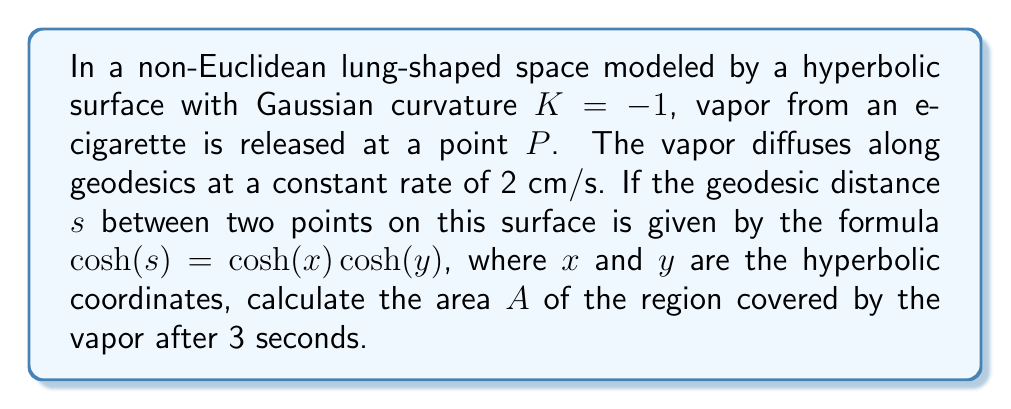Can you answer this question? To solve this problem, we'll follow these steps:

1) In hyperbolic geometry, the area of a circle with radius $r$ is given by:

   $$A = 4\pi\sinh^2(\frac{r}{2})$$

2) The vapor diffuses at a rate of 2 cm/s for 3 seconds, so the radius of the covered region is:

   $$r = 2 \text{ cm/s} \times 3 \text{ s} = 6 \text{ cm}$$

3) Substituting this into the area formula:

   $$A = 4\pi\sinh^2(\frac{6}{2}) = 4\pi\sinh^2(3)$$

4) Calculate $\sinh(3)$:

   $$\sinh(3) = \frac{e^3 - e^{-3}}{2} \approx 10.0178$$

5) Square this value:

   $$\sinh^2(3) \approx 100.3563$$

6) Multiply by $4\pi$:

   $$A = 4\pi \times 100.3563 \approx 1260.3 \text{ cm}^2$$

Therefore, the area covered by the vapor after 3 seconds is approximately 1260.3 square centimeters.
Answer: $1260.3 \text{ cm}^2$ 